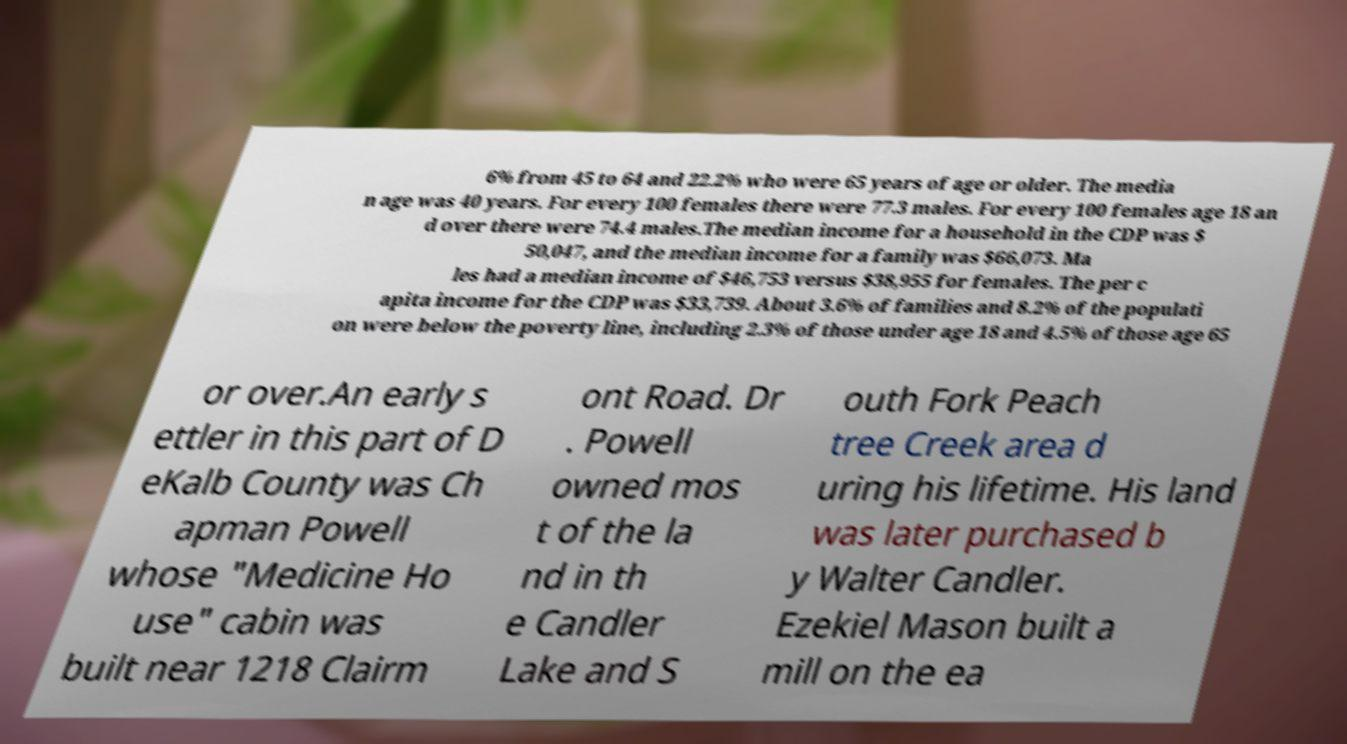Please identify and transcribe the text found in this image. 6% from 45 to 64 and 22.2% who were 65 years of age or older. The media n age was 40 years. For every 100 females there were 77.3 males. For every 100 females age 18 an d over there were 74.4 males.The median income for a household in the CDP was $ 50,047, and the median income for a family was $66,073. Ma les had a median income of $46,753 versus $38,955 for females. The per c apita income for the CDP was $33,739. About 3.6% of families and 8.2% of the populati on were below the poverty line, including 2.3% of those under age 18 and 4.5% of those age 65 or over.An early s ettler in this part of D eKalb County was Ch apman Powell whose "Medicine Ho use" cabin was built near 1218 Clairm ont Road. Dr . Powell owned mos t of the la nd in th e Candler Lake and S outh Fork Peach tree Creek area d uring his lifetime. His land was later purchased b y Walter Candler. Ezekiel Mason built a mill on the ea 